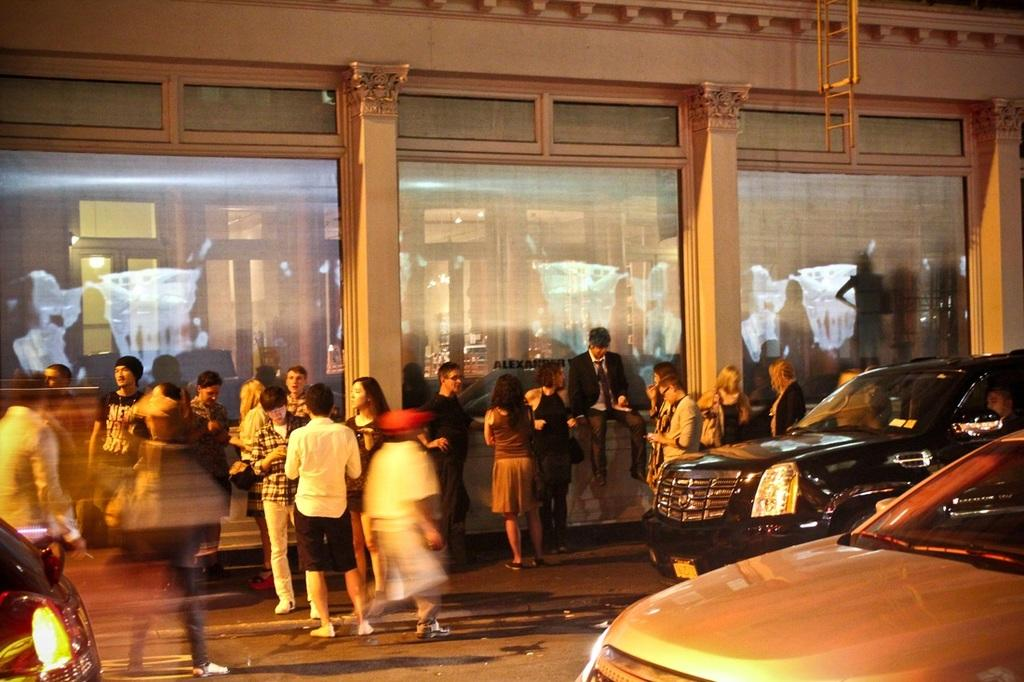What are the people in the image doing? The persons in the image are standing on the road. What else can be seen in the image besides the people? There are vehicles in the image. What is visible in the background of the image? There is a building in the background of the image. What material is present in the image? There is glass visible in the image. How many babies are visible in the image? There are no babies present in the image. What type of teeth can be seen in the image? There are no teeth visible in the image. 